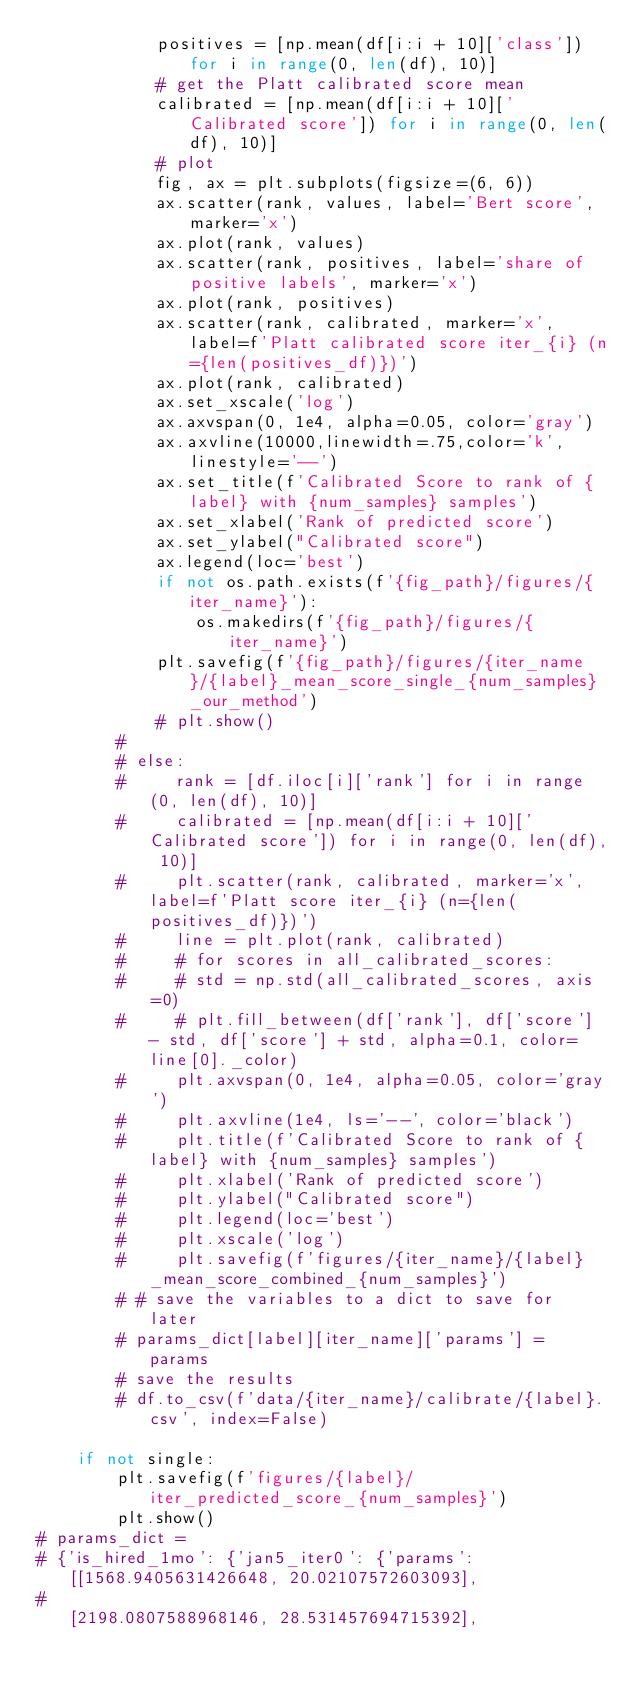<code> <loc_0><loc_0><loc_500><loc_500><_Python_>            positives = [np.mean(df[i:i + 10]['class']) for i in range(0, len(df), 10)]
            # get the Platt calibrated score mean
            calibrated = [np.mean(df[i:i + 10]['Calibrated score']) for i in range(0, len(df), 10)]
            # plot
            fig, ax = plt.subplots(figsize=(6, 6))
            ax.scatter(rank, values, label='Bert score', marker='x')
            ax.plot(rank, values)
            ax.scatter(rank, positives, label='share of positive labels', marker='x')
            ax.plot(rank, positives)
            ax.scatter(rank, calibrated, marker='x', label=f'Platt calibrated score iter_{i} (n={len(positives_df)})')
            ax.plot(rank, calibrated)
            ax.set_xscale('log')
            ax.axvspan(0, 1e4, alpha=0.05, color='gray')
            ax.axvline(10000,linewidth=.75,color='k',linestyle='--')
            ax.set_title(f'Calibrated Score to rank of {label} with {num_samples} samples')
            ax.set_xlabel('Rank of predicted score')
            ax.set_ylabel("Calibrated score")
            ax.legend(loc='best')
            if not os.path.exists(f'{fig_path}/figures/{iter_name}'):
                os.makedirs(f'{fig_path}/figures/{iter_name}')
            plt.savefig(f'{fig_path}/figures/{iter_name}/{label}_mean_score_single_{num_samples}_our_method')
            # plt.show()
        #
        # else:
        #     rank = [df.iloc[i]['rank'] for i in range(0, len(df), 10)]
        #     calibrated = [np.mean(df[i:i + 10]['Calibrated score']) for i in range(0, len(df), 10)]
        #     plt.scatter(rank, calibrated, marker='x', label=f'Platt score iter_{i} (n={len(positives_df)})')
        #     line = plt.plot(rank, calibrated)
        #     # for scores in all_calibrated_scores:
        #     # std = np.std(all_calibrated_scores, axis=0)
        #     # plt.fill_between(df['rank'], df['score'] - std, df['score'] + std, alpha=0.1, color=line[0]._color)
        #     plt.axvspan(0, 1e4, alpha=0.05, color='gray')
        #     plt.axvline(1e4, ls='--', color='black')
        #     plt.title(f'Calibrated Score to rank of {label} with {num_samples} samples')
        #     plt.xlabel('Rank of predicted score')
        #     plt.ylabel("Calibrated score")
        #     plt.legend(loc='best')
        #     plt.xscale('log')
        #     plt.savefig(f'figures/{iter_name}/{label}_mean_score_combined_{num_samples}')
        # # save the variables to a dict to save for later
        # params_dict[label][iter_name]['params'] = params
        # save the results
        # df.to_csv(f'data/{iter_name}/calibrate/{label}.csv', index=False)

    if not single:
        plt.savefig(f'figures/{label}/iter_predicted_score_{num_samples}')
        plt.show()
# params_dict =
# {'is_hired_1mo': {'jan5_iter0': {'params': [[1568.9405631426648, 20.02107572603093],
#                                             [2198.0807588968146, 28.531457694715392],</code> 